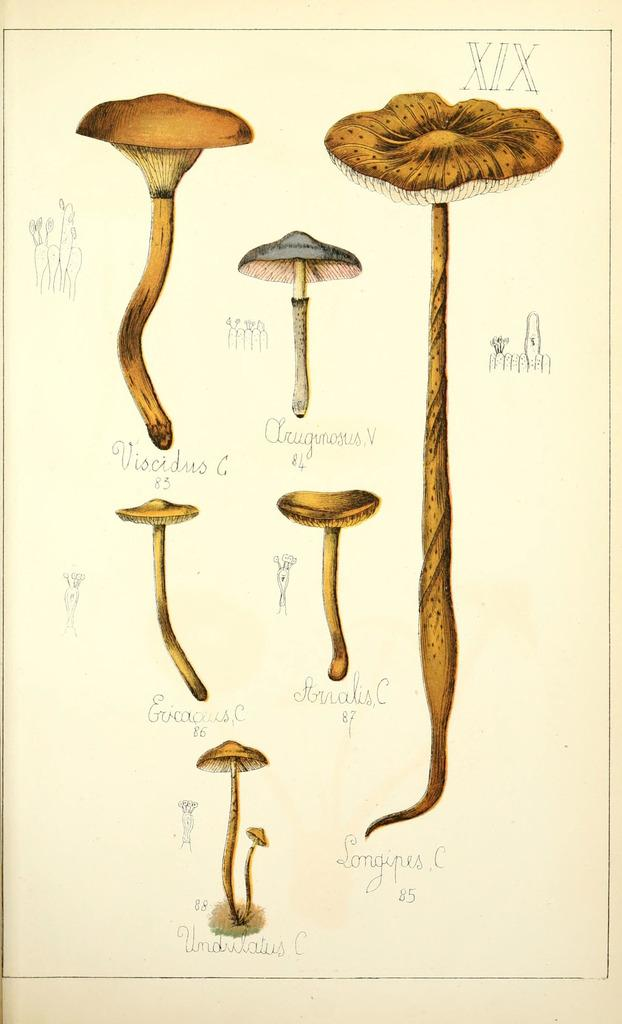What celestial bodies are depicted in the image? There are planets in the image. Can you identify the names of the planets in the image? Yes, the planets have names. Are there any symbols associated with the planets in the image? Yes, the planets have symbols associated with them. What type of throat lozenge is being advertised in the image? There is no throat lozenge or advertisement present in the image; it features planets with names and symbols. 